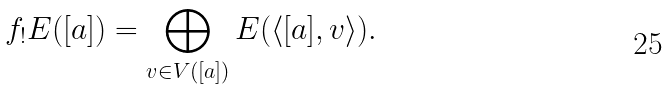Convert formula to latex. <formula><loc_0><loc_0><loc_500><loc_500>f _ { ! } E ( [ a ] ) = \bigoplus _ { v \in V ( [ a ] ) } E ( \langle [ a ] , v \rangle ) .</formula> 